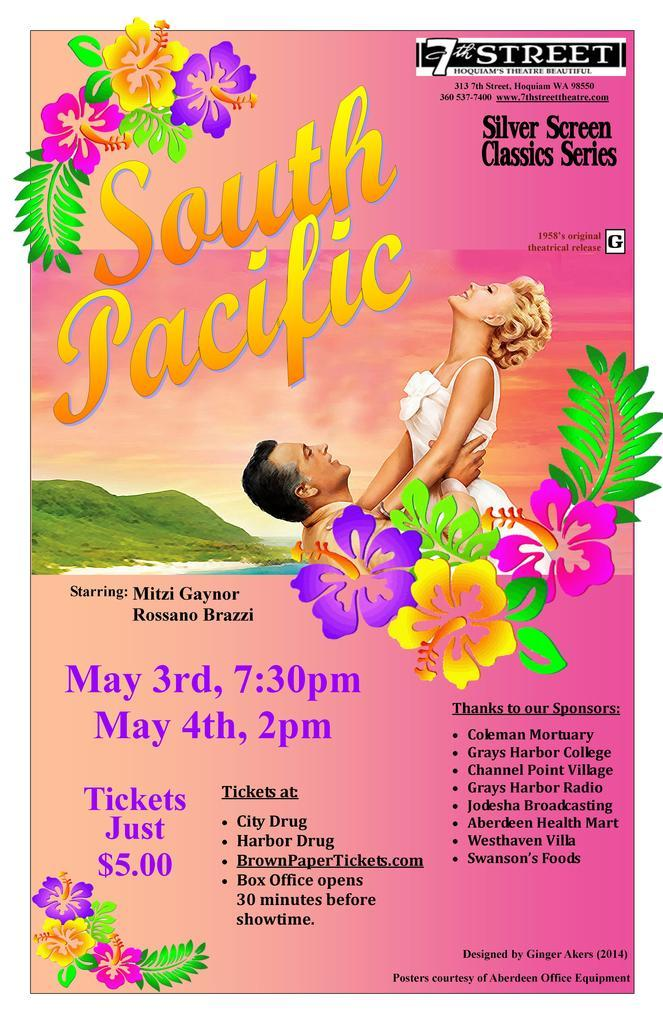How many people are in the image? There is a man and a woman in the image. What can be seen in the background of the image? The image contains hills in the background. What type of decorative elements are present in the image? There are pictures of flowers in the image. Is there any text present in the image? Yes, there is text present in the image. What type of joke is the man telling in the image? There is no joke being told in the image; it only shows a man and a woman. Can you see the woman's finger in the image? The image does not focus on the woman's fingers, so it is not possible to determine if her finger is visible. 